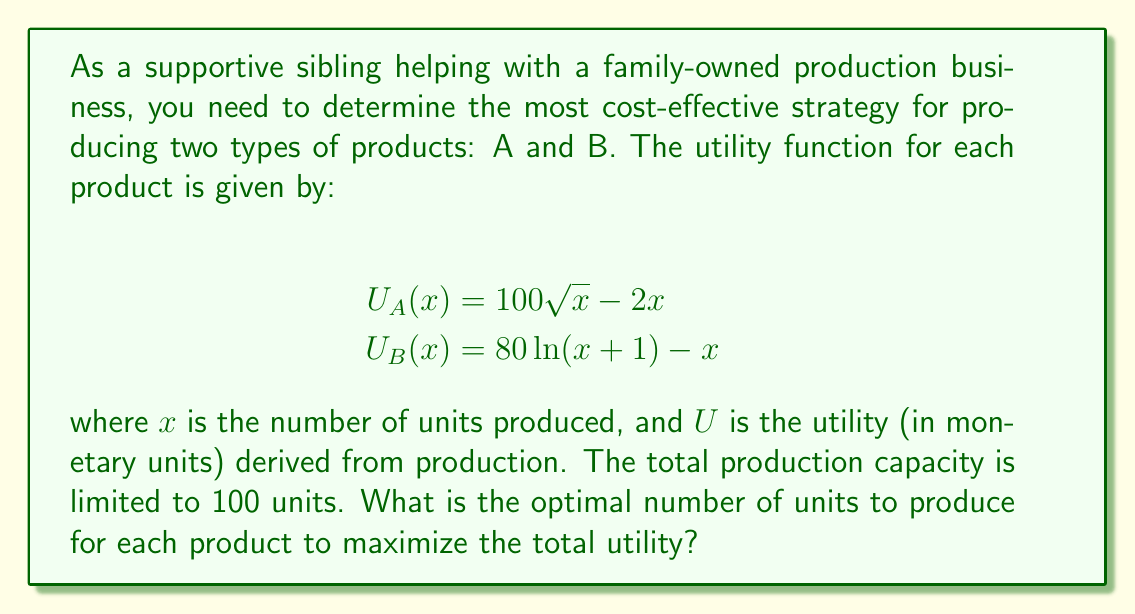What is the answer to this math problem? To solve this problem, we'll follow these steps:

1. Set up the optimization problem:
   We want to maximize the total utility function:
   $$U_{total} = U_A(x_A) + U_B(x_B)$$
   Subject to the constraint: $x_A + x_B = 100$

2. Use the method of Lagrange multipliers:
   Form the Lagrangian function:
   $$L(x_A, x_B, \lambda) = U_A(x_A) + U_B(x_B) + \lambda(100 - x_A - x_B)$$

3. Take partial derivatives and set them equal to zero:
   $$\frac{\partial L}{\partial x_A} = \frac{50}{\sqrt{x_A}} - 2 - \lambda = 0$$
   $$\frac{\partial L}{\partial x_B} = \frac{80}{x_B + 1} - 1 - \lambda = 0$$
   $$\frac{\partial L}{\partial \lambda} = 100 - x_A - x_B = 0$$

4. Solve the system of equations:
   From the first two equations:
   $$\frac{50}{\sqrt{x_A}} - 2 = \frac{80}{x_B + 1} - 1$$
   
   Simplifying:
   $$\frac{50}{\sqrt{x_A}} = \frac{80}{x_B + 1} + 1$$

   Using the constraint $x_B = 100 - x_A$, we can substitute:
   $$\frac{50}{\sqrt{x_A}} = \frac{80}{101 - x_A} + 1$$

5. Solve this equation numerically (e.g., using a graphing calculator or numerical methods):
   We find that $x_A \approx 56.25$

6. Calculate $x_B$ using the constraint:
   $x_B = 100 - x_A \approx 43.75$

7. Round to the nearest whole number, as we can't produce partial units:
   $x_A = 56$ and $x_B = 44$

8. Verify that this solution indeed maximizes the total utility by calculating the total utility for nearby integer solutions.
Answer: The optimal production strategy is to produce 56 units of product A and 44 units of product B. 